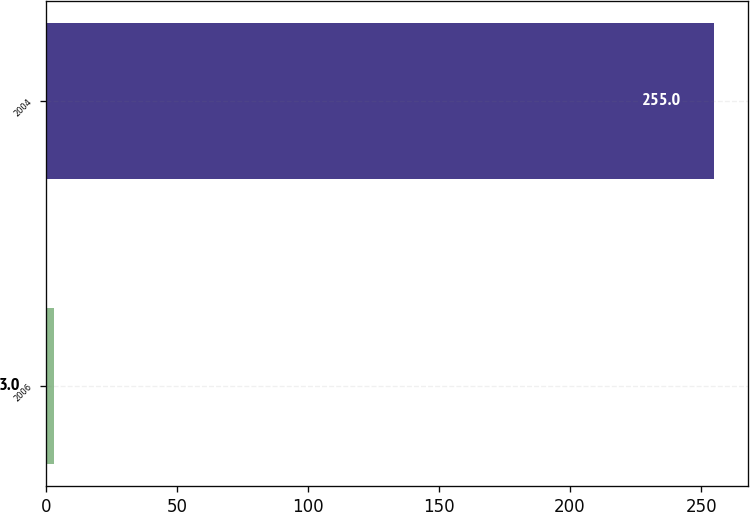<chart> <loc_0><loc_0><loc_500><loc_500><bar_chart><fcel>2006<fcel>2004<nl><fcel>3<fcel>255<nl></chart> 